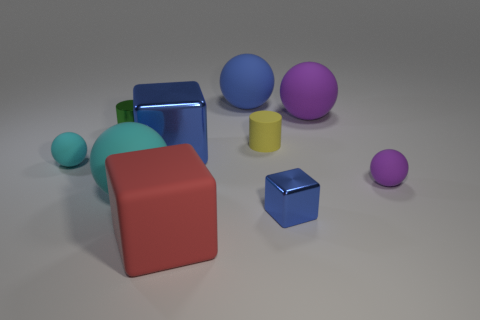There is a green thing that is behind the blue object right of the ball that is behind the big purple rubber sphere; what is its shape?
Your response must be concise. Cylinder. What is the shape of the matte object that is on the right side of the large purple rubber sphere?
Give a very brief answer. Sphere. Is the small yellow object made of the same material as the blue cube right of the rubber cylinder?
Your response must be concise. No. What number of other things are the same shape as the big blue metal object?
Your answer should be very brief. 2. There is a big metallic block; is it the same color as the block on the right side of the yellow thing?
Ensure brevity in your answer.  Yes. There is a purple thing that is behind the small thing on the right side of the tiny blue object; what is its shape?
Your response must be concise. Sphere. What size is the rubber thing that is the same color as the large shiny object?
Keep it short and to the point. Large. Does the tiny matte thing on the left side of the tiny yellow thing have the same shape as the small purple matte object?
Your answer should be very brief. Yes. Are there more blue cubes that are in front of the large red cube than small purple spheres that are behind the large metallic cube?
Make the answer very short. No. What number of cyan rubber balls are behind the tiny sphere to the right of the metal cylinder?
Keep it short and to the point. 1. 